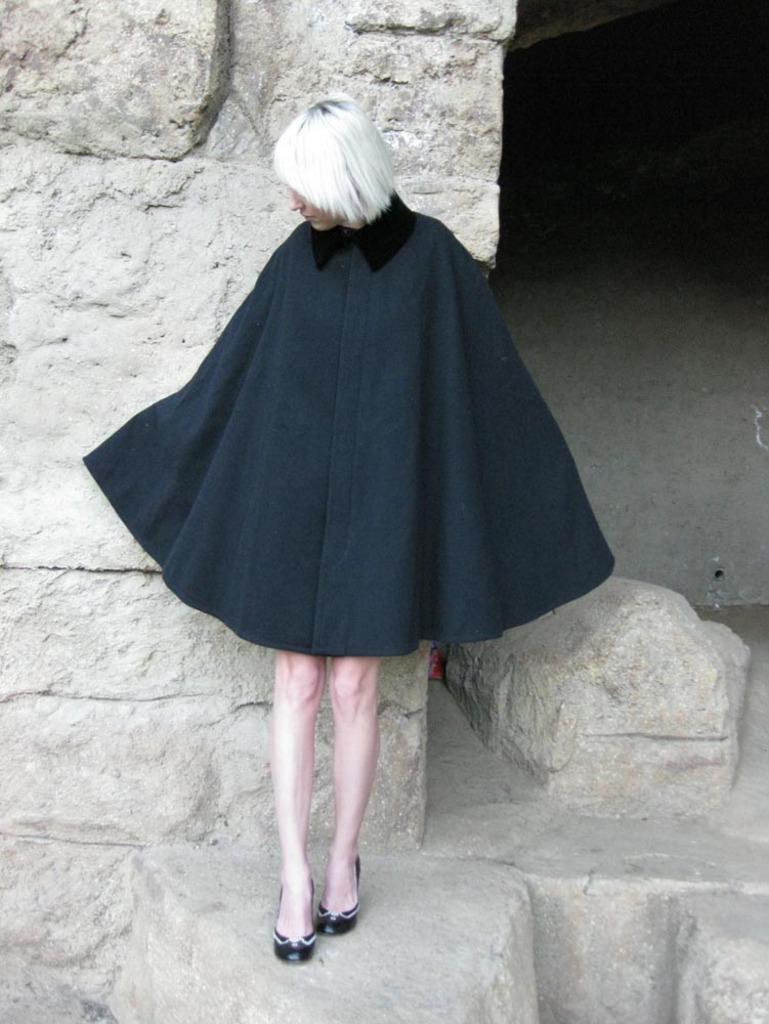Who is the main subject in the picture? There is a woman in the center of the picture. What is the woman wearing? The woman is wearing a black dress. What can be seen behind the woman? There is a wall behind the woman. What type of leather is the woman using to give advice in the image? There is no leather or advice-giving depicted in the image; it features a woman wearing a black dress in the center of the picture with a wall behind her. 